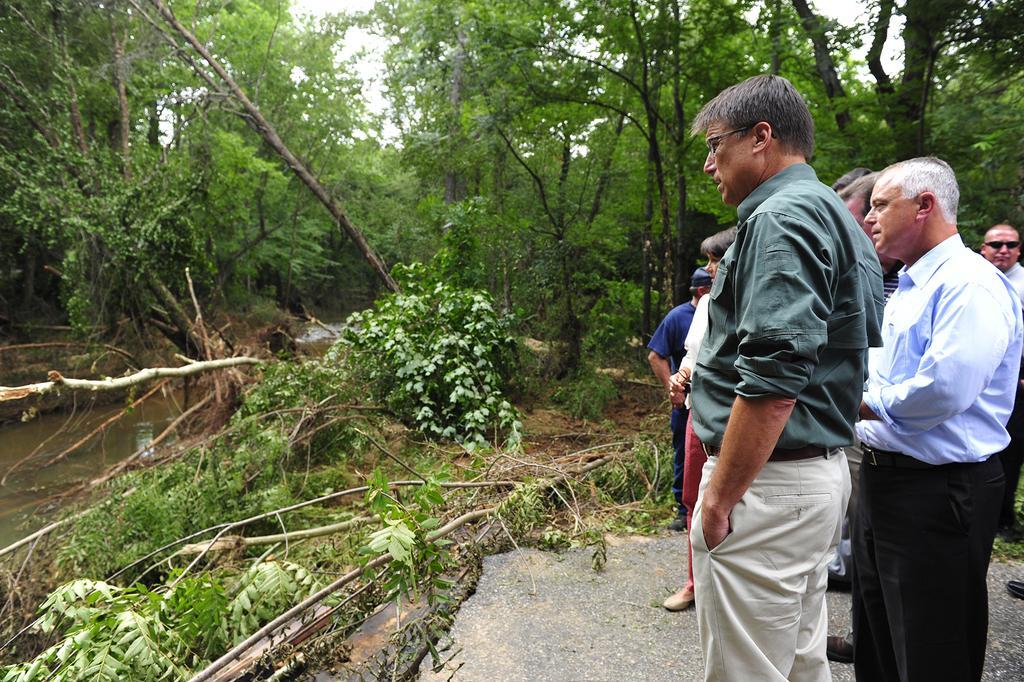Please provide a concise description of this image. In this image we can see these people are standing on the road. Here we can see a few trees has fallen on the ground, we can see water, trees and the sky in the background. 